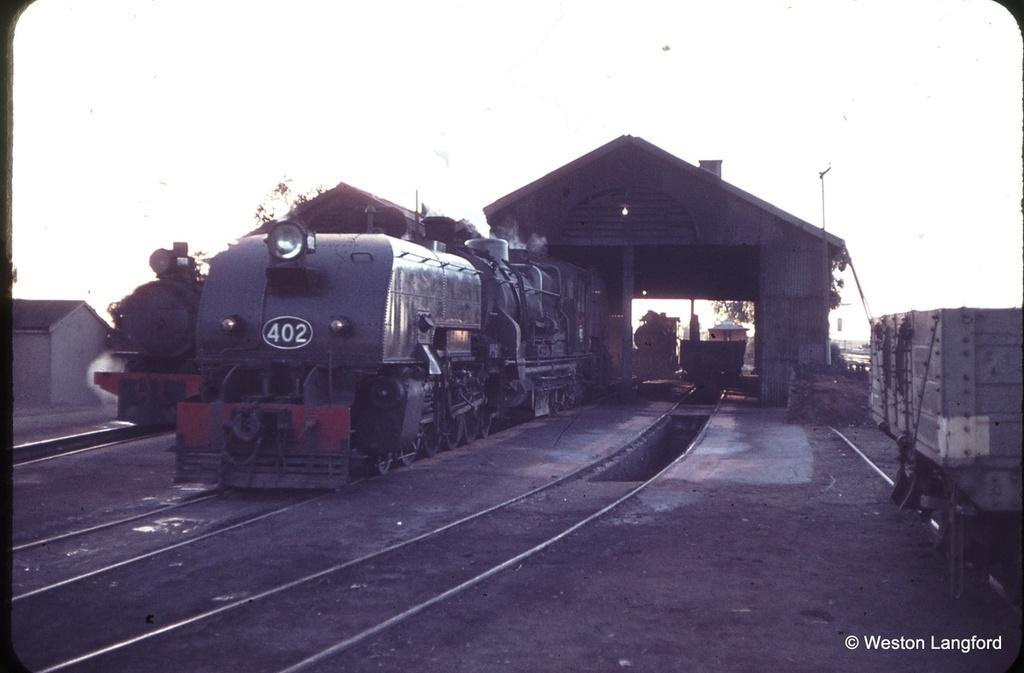Could you give a brief overview of what you see in this image? In this picture we can see trains on railway tracks, shelters, trees, house and some objects and in the background we can see the sky. 